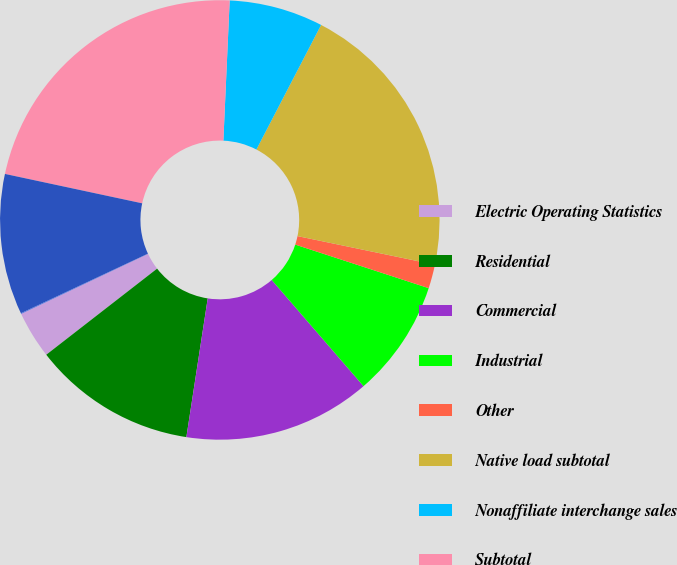<chart> <loc_0><loc_0><loc_500><loc_500><pie_chart><fcel>Electric Operating Statistics<fcel>Residential<fcel>Commercial<fcel>Industrial<fcel>Other<fcel>Native load subtotal<fcel>Nonaffiliate interchange sales<fcel>Subtotal<fcel>Generation and delivery<fcel>Delivery service only<nl><fcel>3.48%<fcel>12.06%<fcel>13.78%<fcel>8.63%<fcel>1.76%<fcel>20.64%<fcel>6.91%<fcel>22.36%<fcel>10.34%<fcel>0.05%<nl></chart> 